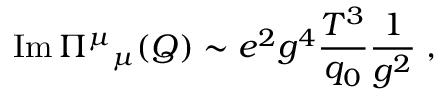Convert formula to latex. <formula><loc_0><loc_0><loc_500><loc_500>I m \, ^ { \mu _ { \mu } ( Q ) \sim e ^ { 2 } g ^ { 4 } { \frac { T ^ { 3 } } { q _ { 0 } } } { \frac { 1 } { g ^ { 2 } } } \, ,</formula> 